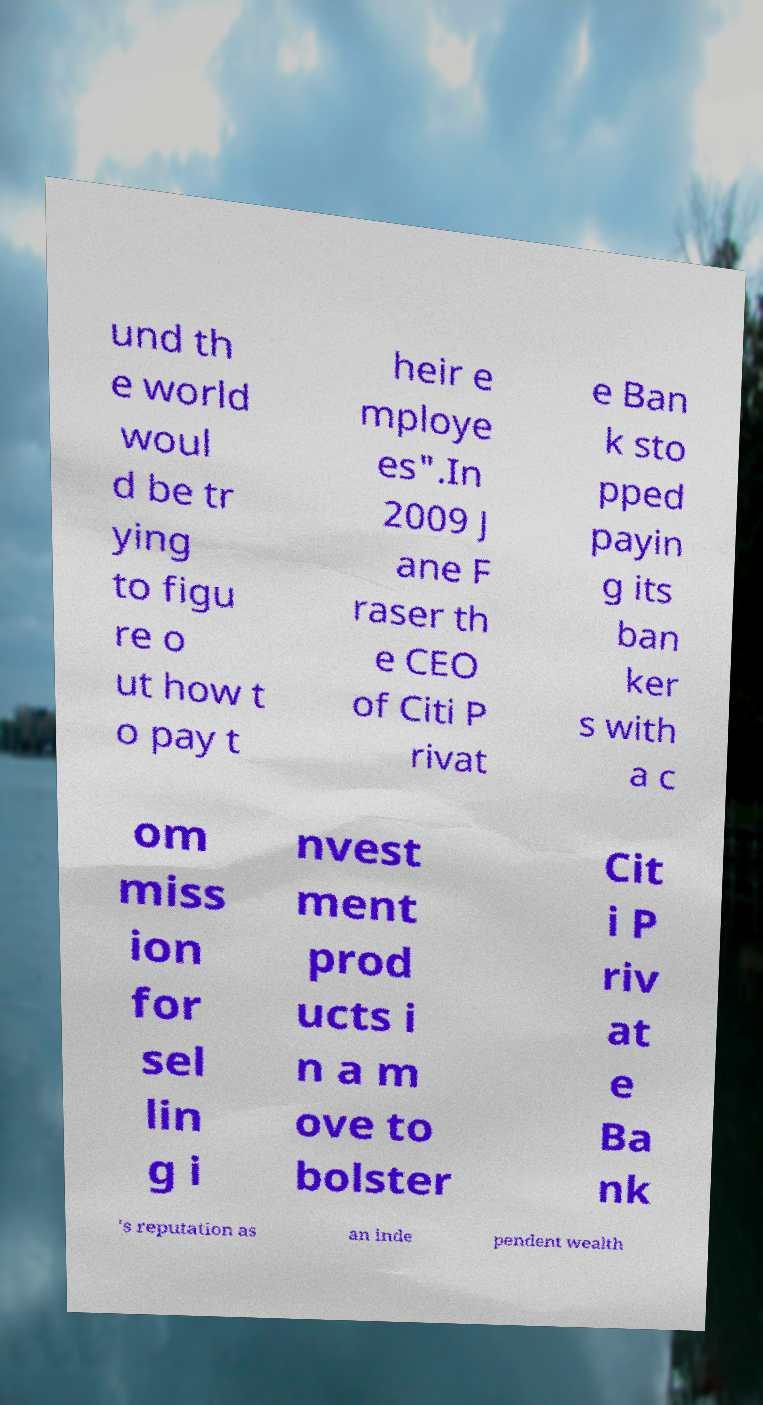What messages or text are displayed in this image? I need them in a readable, typed format. und th e world woul d be tr ying to figu re o ut how t o pay t heir e mploye es".In 2009 J ane F raser th e CEO of Citi P rivat e Ban k sto pped payin g its ban ker s with a c om miss ion for sel lin g i nvest ment prod ucts i n a m ove to bolster Cit i P riv at e Ba nk 's reputation as an inde pendent wealth 